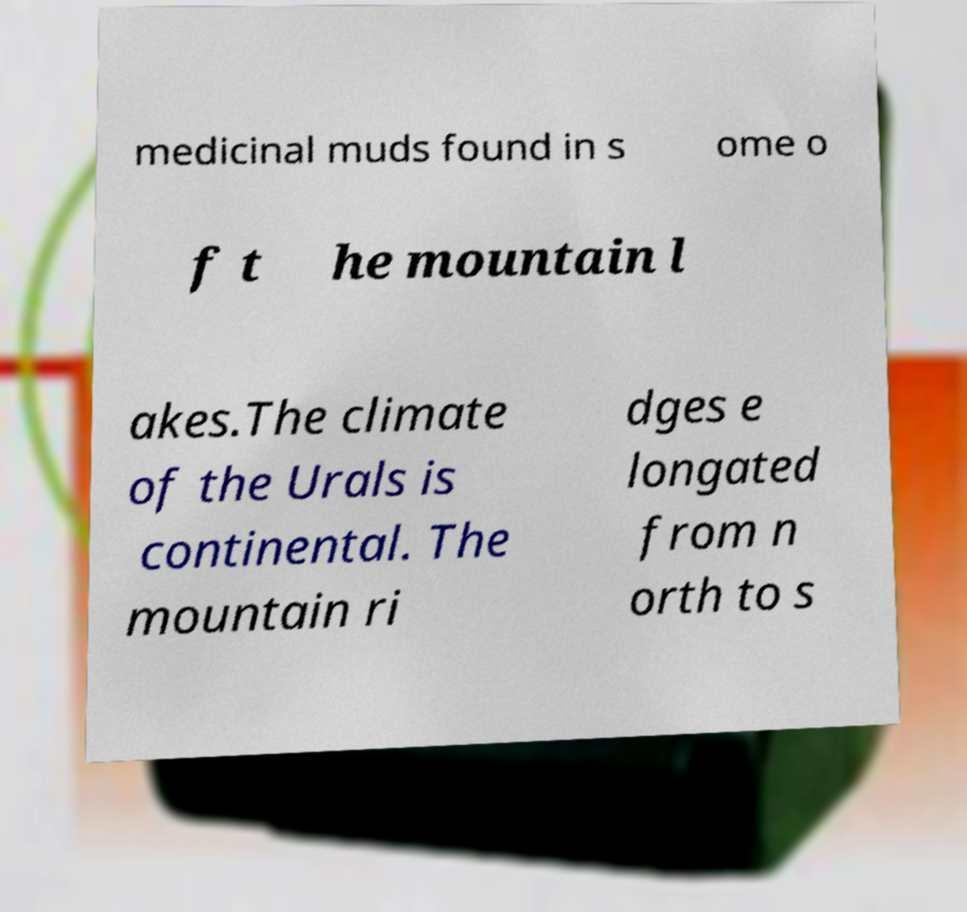What messages or text are displayed in this image? I need them in a readable, typed format. medicinal muds found in s ome o f t he mountain l akes.The climate of the Urals is continental. The mountain ri dges e longated from n orth to s 